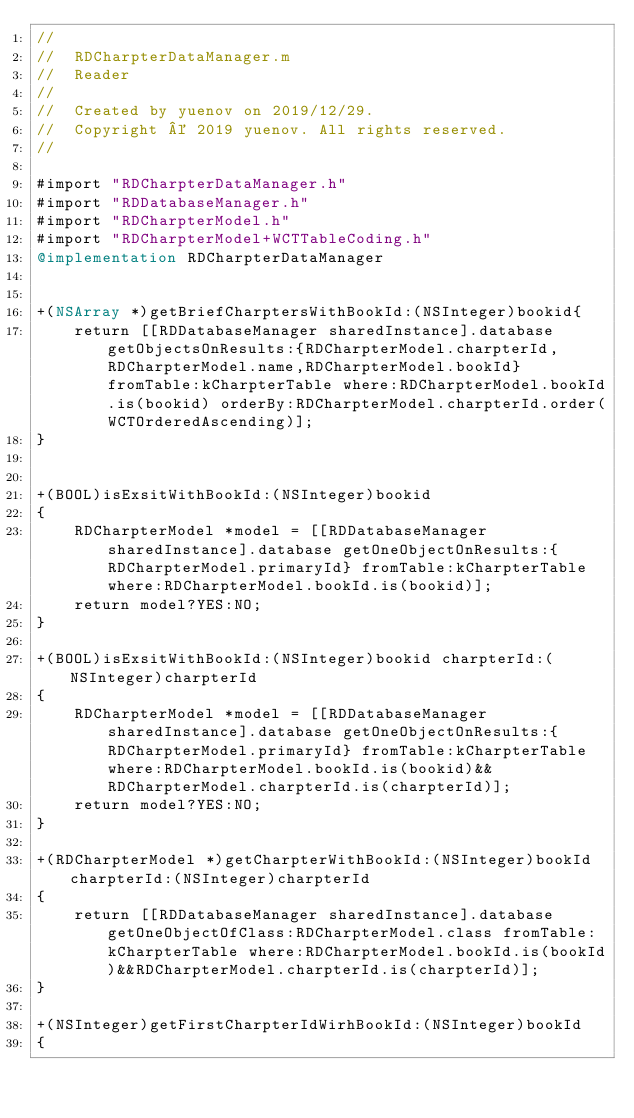<code> <loc_0><loc_0><loc_500><loc_500><_ObjectiveC_>//
//  RDCharpterDataManager.m
//  Reader
//
//  Created by yuenov on 2019/12/29.
//  Copyright © 2019 yuenov. All rights reserved.
//

#import "RDCharpterDataManager.h"
#import "RDDatabaseManager.h"
#import "RDCharpterModel.h"
#import "RDCharpterModel+WCTTableCoding.h"
@implementation RDCharpterDataManager


+(NSArray *)getBriefCharptersWithBookId:(NSInteger)bookid{
    return [[RDDatabaseManager sharedInstance].database getObjectsOnResults:{RDCharpterModel.charpterId,RDCharpterModel.name,RDCharpterModel.bookId} fromTable:kCharpterTable where:RDCharpterModel.bookId.is(bookid) orderBy:RDCharpterModel.charpterId.order(WCTOrderedAscending)];
}


+(BOOL)isExsitWithBookId:(NSInteger)bookid
{
    RDCharpterModel *model = [[RDDatabaseManager sharedInstance].database getOneObjectOnResults:{RDCharpterModel.primaryId} fromTable:kCharpterTable where:RDCharpterModel.bookId.is(bookid)];
    return model?YES:NO;
}

+(BOOL)isExsitWithBookId:(NSInteger)bookid charpterId:(NSInteger)charpterId
{
    RDCharpterModel *model = [[RDDatabaseManager sharedInstance].database getOneObjectOnResults:{RDCharpterModel.primaryId} fromTable:kCharpterTable where:RDCharpterModel.bookId.is(bookid)&&RDCharpterModel.charpterId.is(charpterId)];
    return model?YES:NO;
}

+(RDCharpterModel *)getCharpterWithBookId:(NSInteger)bookId charpterId:(NSInteger)charpterId
{
    return [[RDDatabaseManager sharedInstance].database getOneObjectOfClass:RDCharpterModel.class fromTable:kCharpterTable where:RDCharpterModel.bookId.is(bookId)&&RDCharpterModel.charpterId.is(charpterId)];
}

+(NSInteger)getFirstCharpterIdWirhBookId:(NSInteger)bookId
{</code> 